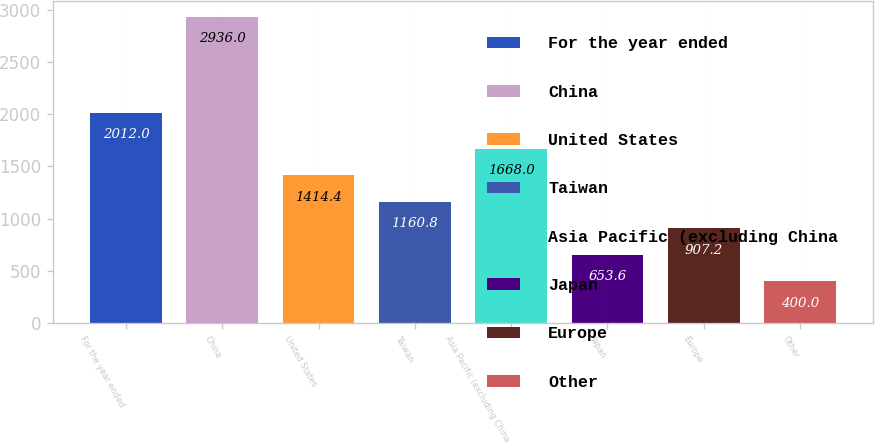Convert chart to OTSL. <chart><loc_0><loc_0><loc_500><loc_500><bar_chart><fcel>For the year ended<fcel>China<fcel>United States<fcel>Taiwan<fcel>Asia Pacific (excluding China<fcel>Japan<fcel>Europe<fcel>Other<nl><fcel>2012<fcel>2936<fcel>1414.4<fcel>1160.8<fcel>1668<fcel>653.6<fcel>907.2<fcel>400<nl></chart> 